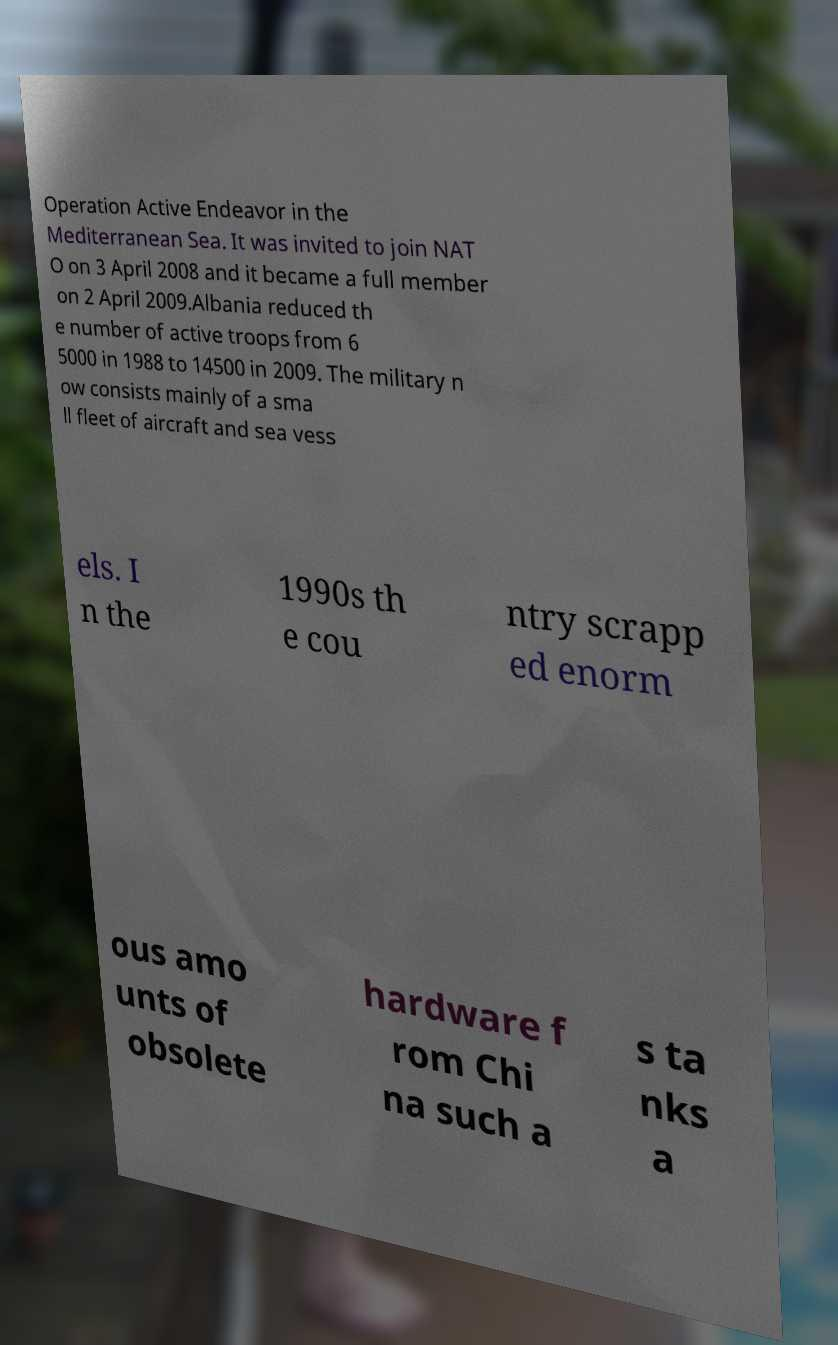For documentation purposes, I need the text within this image transcribed. Could you provide that? Operation Active Endeavor in the Mediterranean Sea. It was invited to join NAT O on 3 April 2008 and it became a full member on 2 April 2009.Albania reduced th e number of active troops from 6 5000 in 1988 to 14500 in 2009. The military n ow consists mainly of a sma ll fleet of aircraft and sea vess els. I n the 1990s th e cou ntry scrapp ed enorm ous amo unts of obsolete hardware f rom Chi na such a s ta nks a 